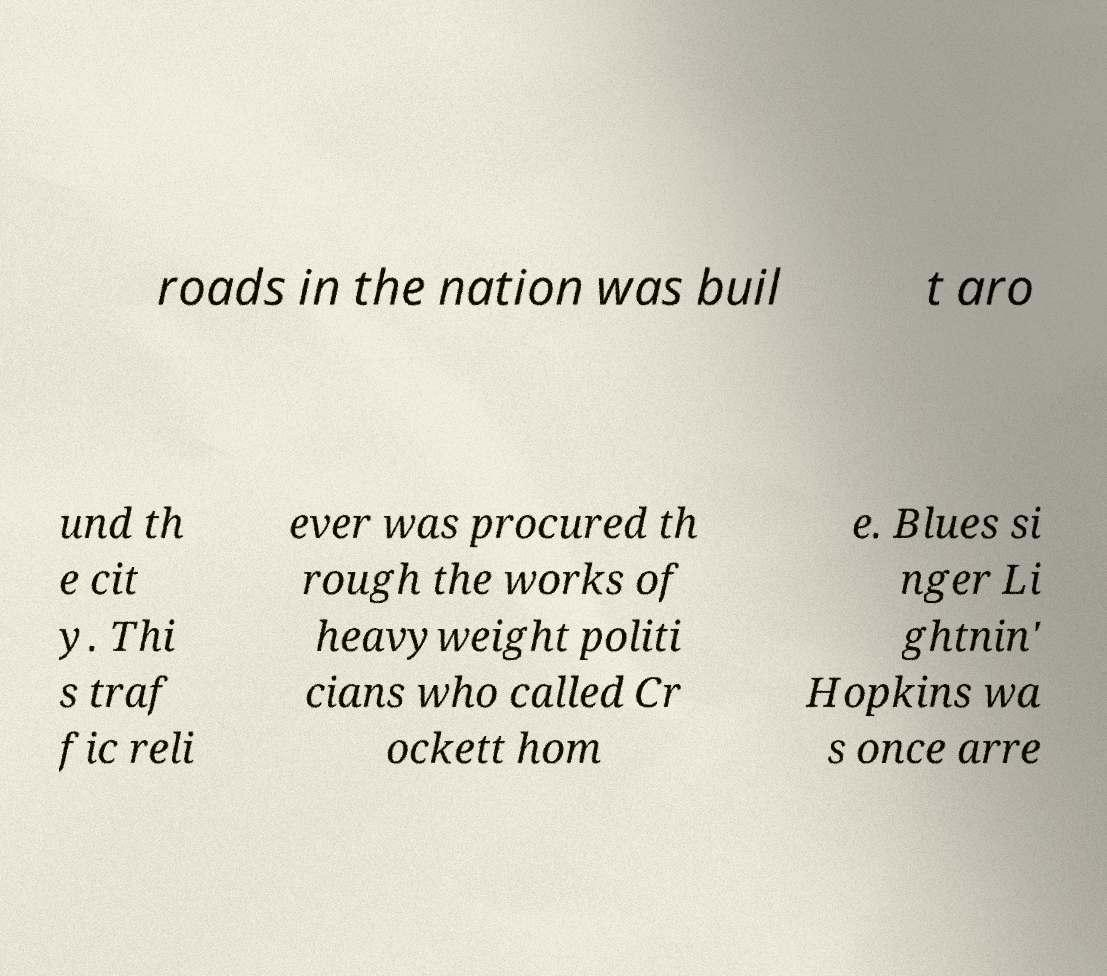Can you accurately transcribe the text from the provided image for me? roads in the nation was buil t aro und th e cit y. Thi s traf fic reli ever was procured th rough the works of heavyweight politi cians who called Cr ockett hom e. Blues si nger Li ghtnin' Hopkins wa s once arre 